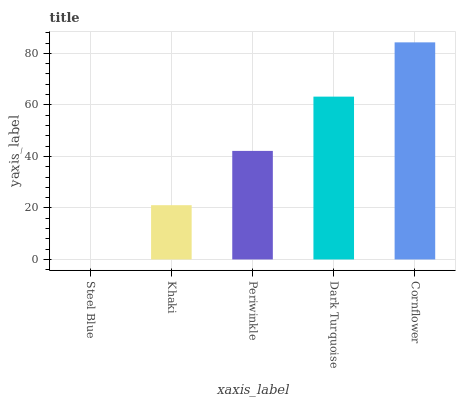Is Steel Blue the minimum?
Answer yes or no. Yes. Is Cornflower the maximum?
Answer yes or no. Yes. Is Khaki the minimum?
Answer yes or no. No. Is Khaki the maximum?
Answer yes or no. No. Is Khaki greater than Steel Blue?
Answer yes or no. Yes. Is Steel Blue less than Khaki?
Answer yes or no. Yes. Is Steel Blue greater than Khaki?
Answer yes or no. No. Is Khaki less than Steel Blue?
Answer yes or no. No. Is Periwinkle the high median?
Answer yes or no. Yes. Is Periwinkle the low median?
Answer yes or no. Yes. Is Steel Blue the high median?
Answer yes or no. No. Is Steel Blue the low median?
Answer yes or no. No. 